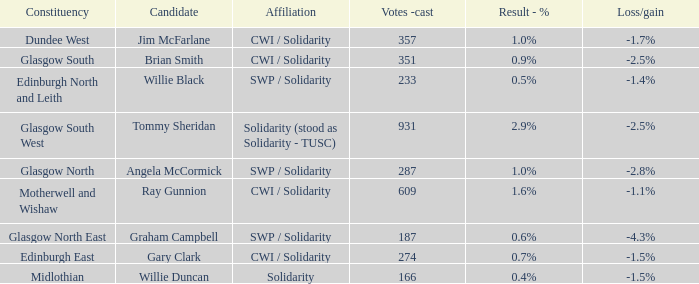4%? Willie Duncan. 